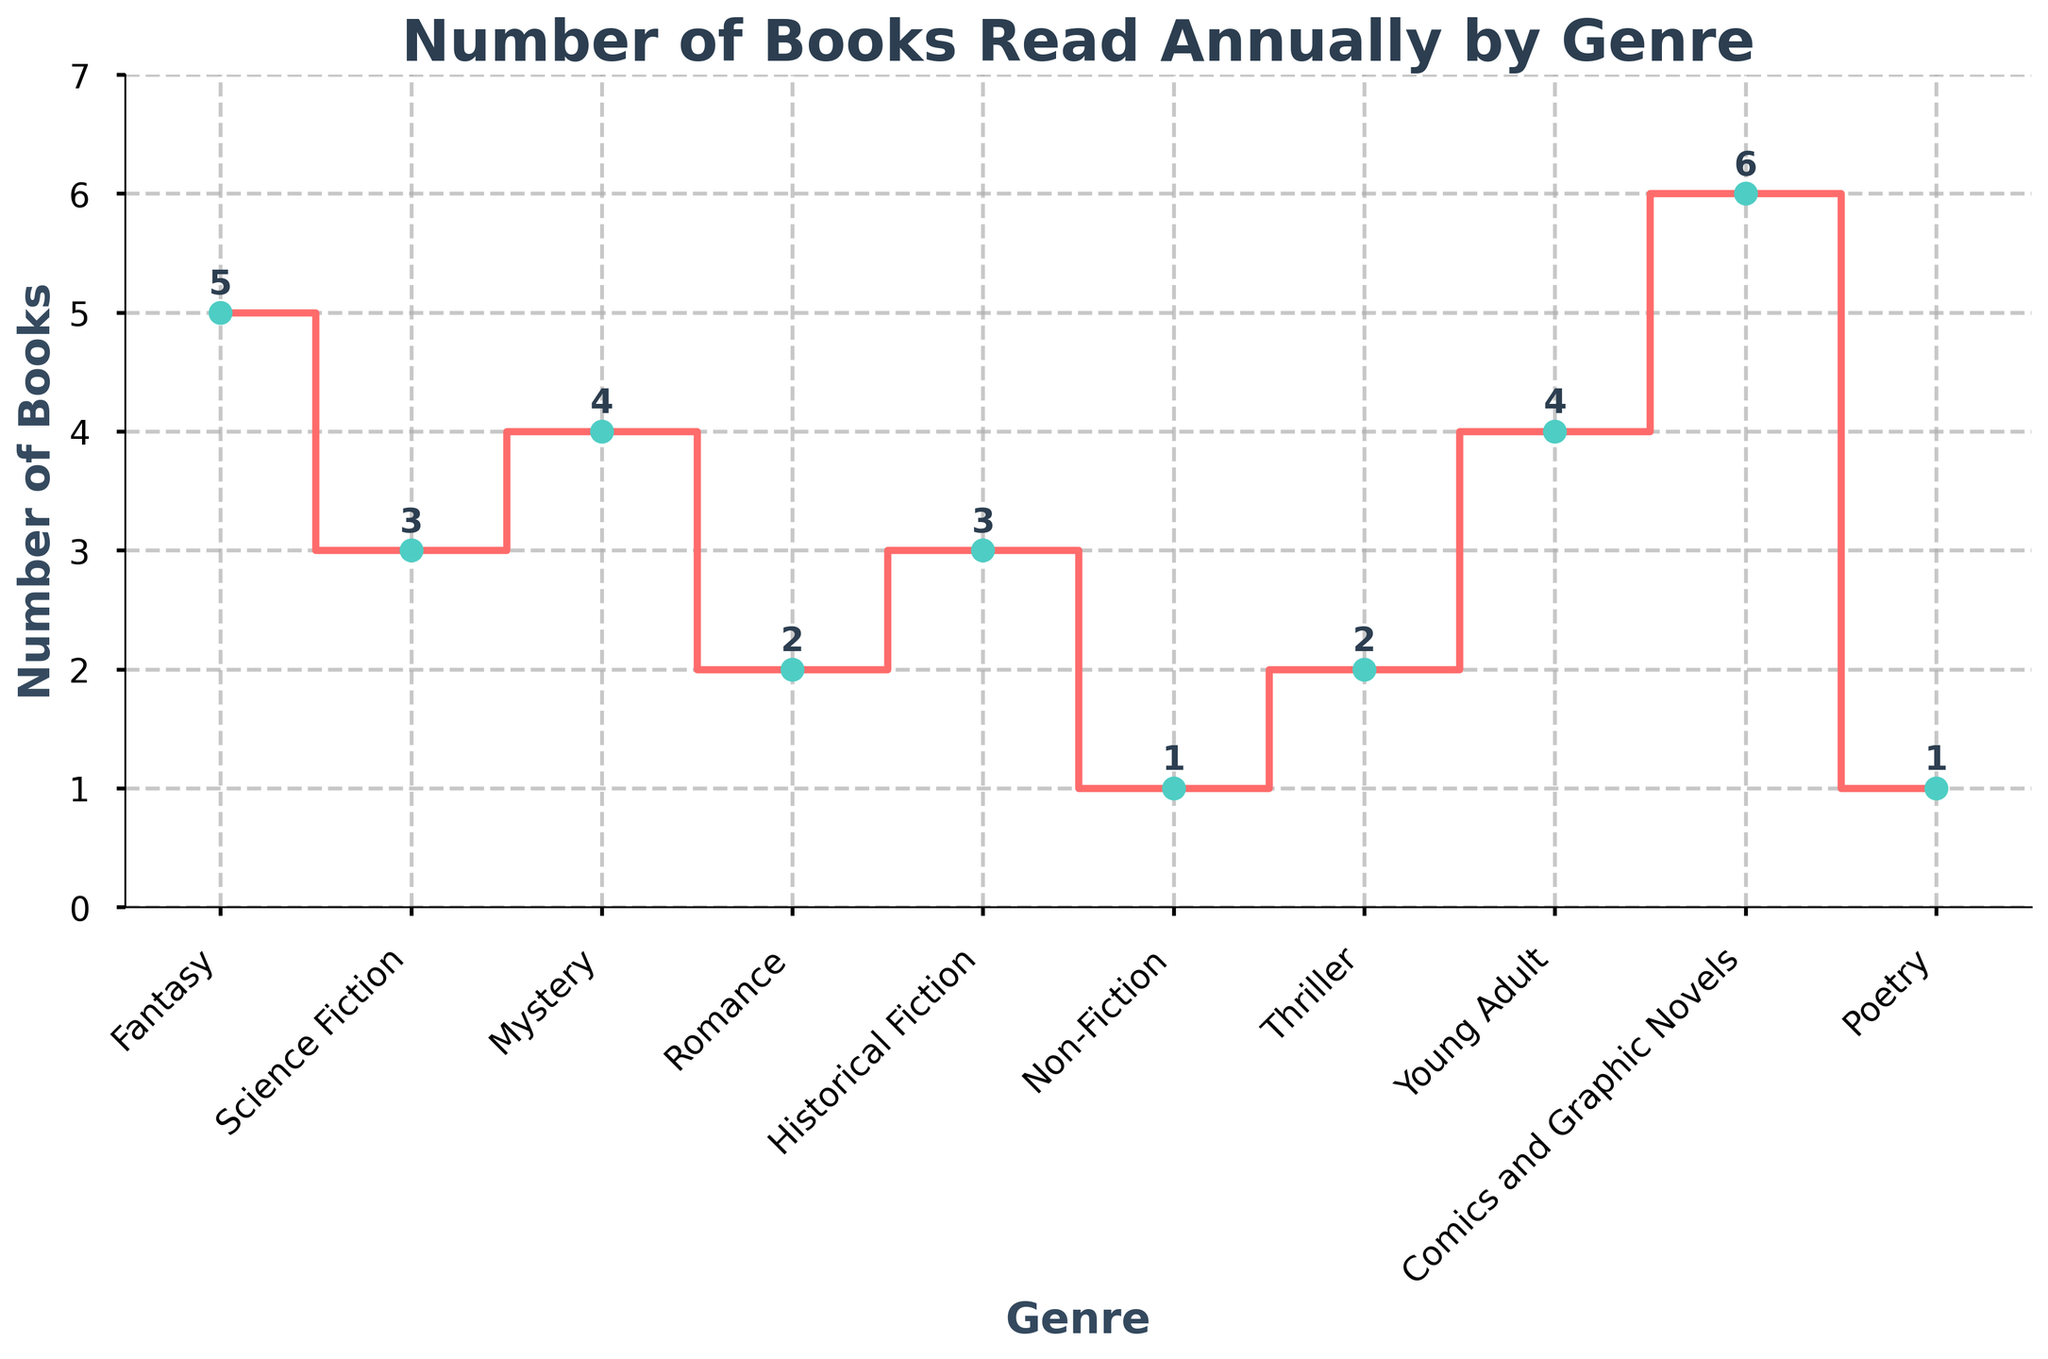What's the title of the plot? The title is located at the top center of the plot and usually provides a summary of the data being presented.
Answer: Number of Books Read Annually by Genre How many genres are displayed in the plot? Count the number of distinct categories along the x-axis.
Answer: 10 What genre has the highest number of books read? Find the data point that reaches the highest value on the y-axis and match it to its corresponding genre on the x-axis.
Answer: Comics and Graphic Novels Which genre has the least number of books read, and how many? Find the data point that reaches the lowest value on the y-axis and match it to its corresponding genre on the x-axis.
Answer: Non-Fiction and Poetry, 1 What is the difference between the number of Fantasy and Romance books read? Subtract the number of Romance books from the number of Fantasy books read.
Answer: 3 Which genres have an equal number of books read? Find genres that have matching y-axis values and list them.
Answer: Science Fiction and Historical Fiction, Mystery and Young Adult, Romance and Thriller, Non-Fiction and Poetry What is the average number of books read across all genres? Add the total number of books read for all genres and then divide by the number of genres. (5+3+4+2+3+1+2+4+6+1) = 31. Then, 31 / 10.
Answer: 3.1 How many more books are read in Fantasy compared to Mystery? Subtract the number of Mystery books from the number of Fantasy books.
Answer: 1 Between which two genres is the steepest increase in books read observed? Look for the segment with the largest vertical distance between two consecutive genres.
Answer: Between Poetry and Comics and Graphic Novels What is the total number of books read in the non-fiction genres (Non-Fiction and Historical Fiction)? Add the number of books read in Non-Fiction and Historical Fiction.
Answer: 4 